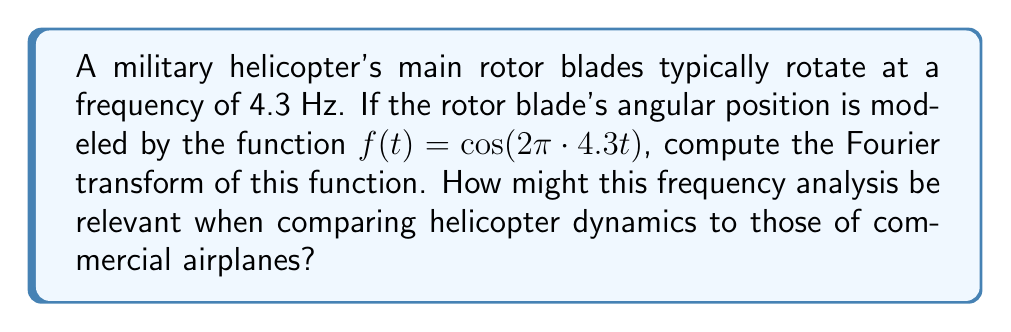Show me your answer to this math problem. Let's approach this step-by-step:

1) The general form of the Fourier transform is:

   $$F(\omega) = \int_{-\infty}^{\infty} f(t) e^{-i\omega t} dt$$

2) Our function is $f(t) = \cos(2\pi \cdot 4.3t)$. Let's call $2\pi \cdot 4.3 = \omega_0$, so $f(t) = \cos(\omega_0 t)$.

3) We can use Euler's formula to express the cosine function:

   $$\cos(\omega_0 t) = \frac{1}{2}(e^{i\omega_0 t} + e^{-i\omega_0 t})$$

4) Substituting this into our Fourier transform:

   $$F(\omega) = \int_{-\infty}^{\infty} \frac{1}{2}(e^{i\omega_0 t} + e^{-i\omega_0 t}) e^{-i\omega t} dt$$

5) This can be separated into two integrals:

   $$F(\omega) = \frac{1}{2}\int_{-\infty}^{\infty} e^{i(\omega_0-\omega) t} dt + \frac{1}{2}\int_{-\infty}^{\infty} e^{-i(\omega_0+\omega) t} dt$$

6) Each of these integrals results in a Dirac delta function:

   $$F(\omega) = \pi[\delta(\omega - \omega_0) + \delta(\omega + \omega_0)]$$

7) Substituting back $\omega_0 = 2\pi \cdot 4.3$:

   $$F(\omega) = \pi[\delta(\omega - 2\pi \cdot 4.3) + \delta(\omega + 2\pi \cdot 4.3)]$$

This result shows two impulses in the frequency domain, one at 4.3 Hz and one at -4.3 Hz, which is characteristic of a pure cosine wave.

For a military enthusiast, this analysis is relevant when comparing helicopters to commercial airplanes. The distinct frequency of the rotor blades creates a unique vibration signature that differs significantly from the smoother, higher-frequency vibrations typically experienced in fixed-wing aircraft. This frequency analysis could be crucial for vibration control, structural integrity assessments, and even in developing stealth technologies to minimize the helicopter's acoustic signature.
Answer: $F(\omega) = \pi[\delta(\omega - 2\pi \cdot 4.3) + \delta(\omega + 2\pi \cdot 4.3)]$ 